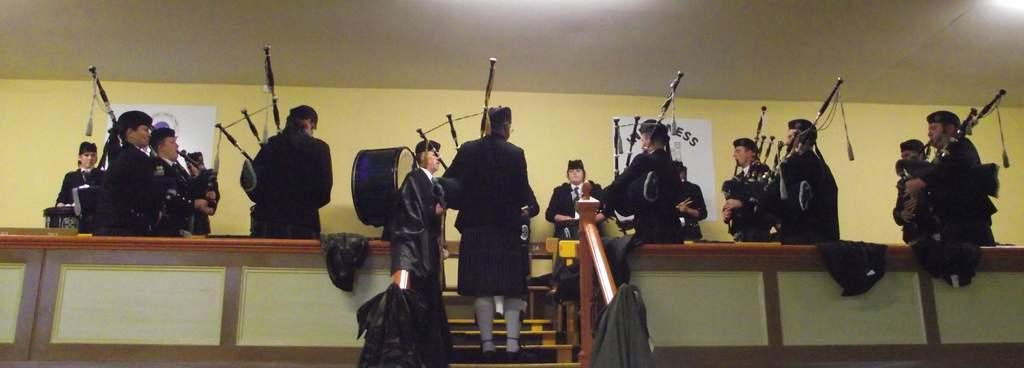How many people are in the image? There are many people in the image. What are the people doing in the image? The people are standing and playing bagpipes. What color are the uniforms that the people are wearing? The people are wearing black uniforms. What type of footwear can be seen on the people in the image? The people are wearing white socks. What type of headwear are the people wearing in the image? The people are wearing caps. Can you see any rail tracks or an ocean in the image? No, there are no rail tracks or ocean visible in the image. Is there a bathtub or any water-related activity in the image? No, there is no bathtub or water-related activity present in the image. 